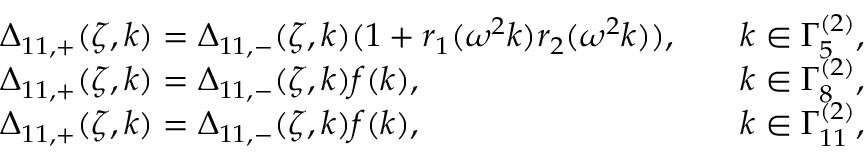Convert formula to latex. <formula><loc_0><loc_0><loc_500><loc_500>\begin{array} { r l r l } & { \Delta _ { 1 1 , + } ( \zeta , k ) = \Delta _ { 1 1 , - } ( \zeta , k ) ( 1 + r _ { 1 } ( \omega ^ { 2 } k ) r _ { 2 } ( \omega ^ { 2 } k ) ) , } & & { k \in \Gamma _ { 5 } ^ { ( 2 ) } , } \\ & { \Delta _ { 1 1 , + } ( \zeta , k ) = \Delta _ { 1 1 , - } ( \zeta , k ) f ( k ) , } & & { k \in \Gamma _ { 8 } ^ { ( 2 ) } , } \\ & { \Delta _ { 1 1 , + } ( \zeta , k ) = \Delta _ { 1 1 , - } ( \zeta , k ) f ( k ) , } & & { k \in \Gamma _ { 1 1 } ^ { ( 2 ) } , } \end{array}</formula> 